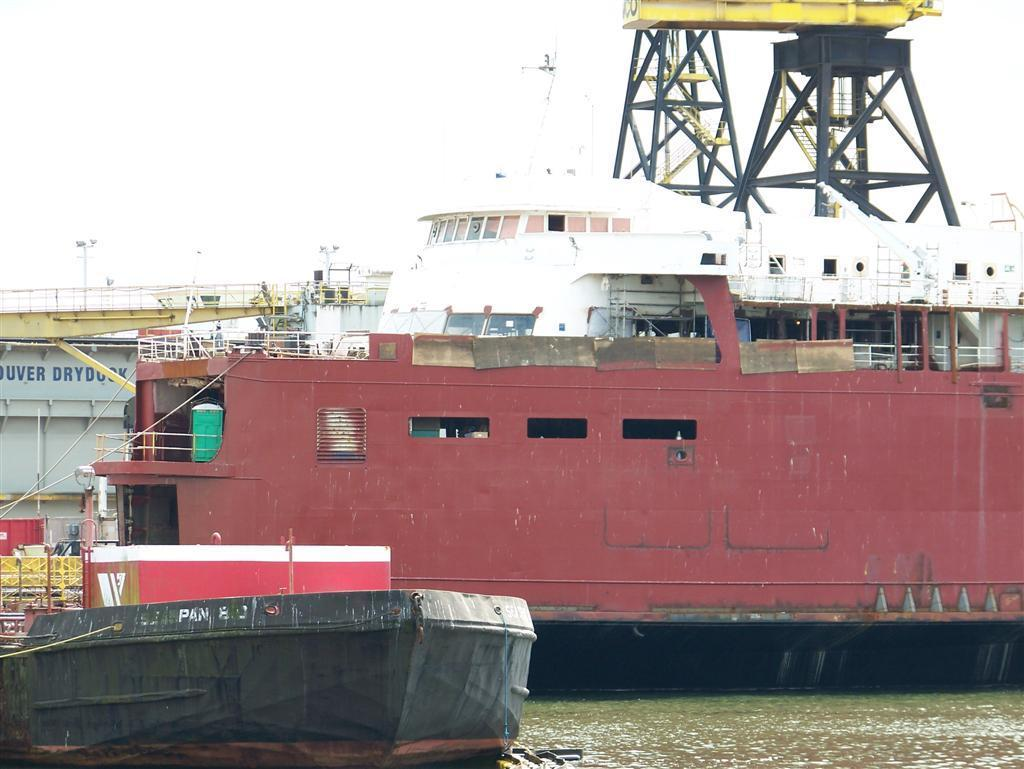What type of watercraft can be seen in the image? There is a ship and a boat in the image. Where are the ship and boat located? Both the ship and boat are on the water. What can be found on the ship? There are objects on the ship. What can be seen in the background of the image? There are flowers, a fence, pole lights, and other unspecified objects in the background of the image. What type of bell can be heard ringing in the image? There is no bell present in the image, and therefore no sound can be heard. 